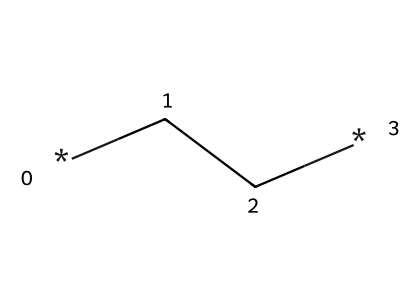What is the molecular formula of polyethylene? Polyethylene is a polymer made from repeating units of ethylene, represented by the formula (C2H4)n, which indicates a repeating structure of two carbon atoms and four hydrogen atoms.
Answer: C2H4 How many carbon atoms are in the structural formula of polyethylene? The SMILES representation "CC" indicates that there are two carbon atoms present in the structure.
Answer: 2 What type of polymer is polyethylene classified as? Polyethylene, made from the polymerization of ethylene, is classified as a saturated hydrocarbon, specifically an addition polymer due to its formation through the addition of monomers.
Answer: addition polymer What type of intermolecular forces are present in polyethylene? Polyethylene primarily exhibits van der Waals forces, which are weak, non-covalent attractions between the long hydrocarbon chains of the polymer.
Answer: van der Waals forces Describe the physical state of polyethylene at room temperature. Given the long chains of polyethylene and the nature of its intermolecular forces, it is typically a solid at room temperature.
Answer: solid What is one common application of polyethylene in photography? Polyethylene is widely used for archival storage bags due to its chemical stability and non-reactivity, preventing damage to photographic negatives.
Answer: archival storage bags What property of polyethylene contributes to its use in preventing deterioration of photographic materials? The chemical inertness of polyethylene means it does not react with the materials it stores, providing effective protection against deterioration.
Answer: chemical inertness 